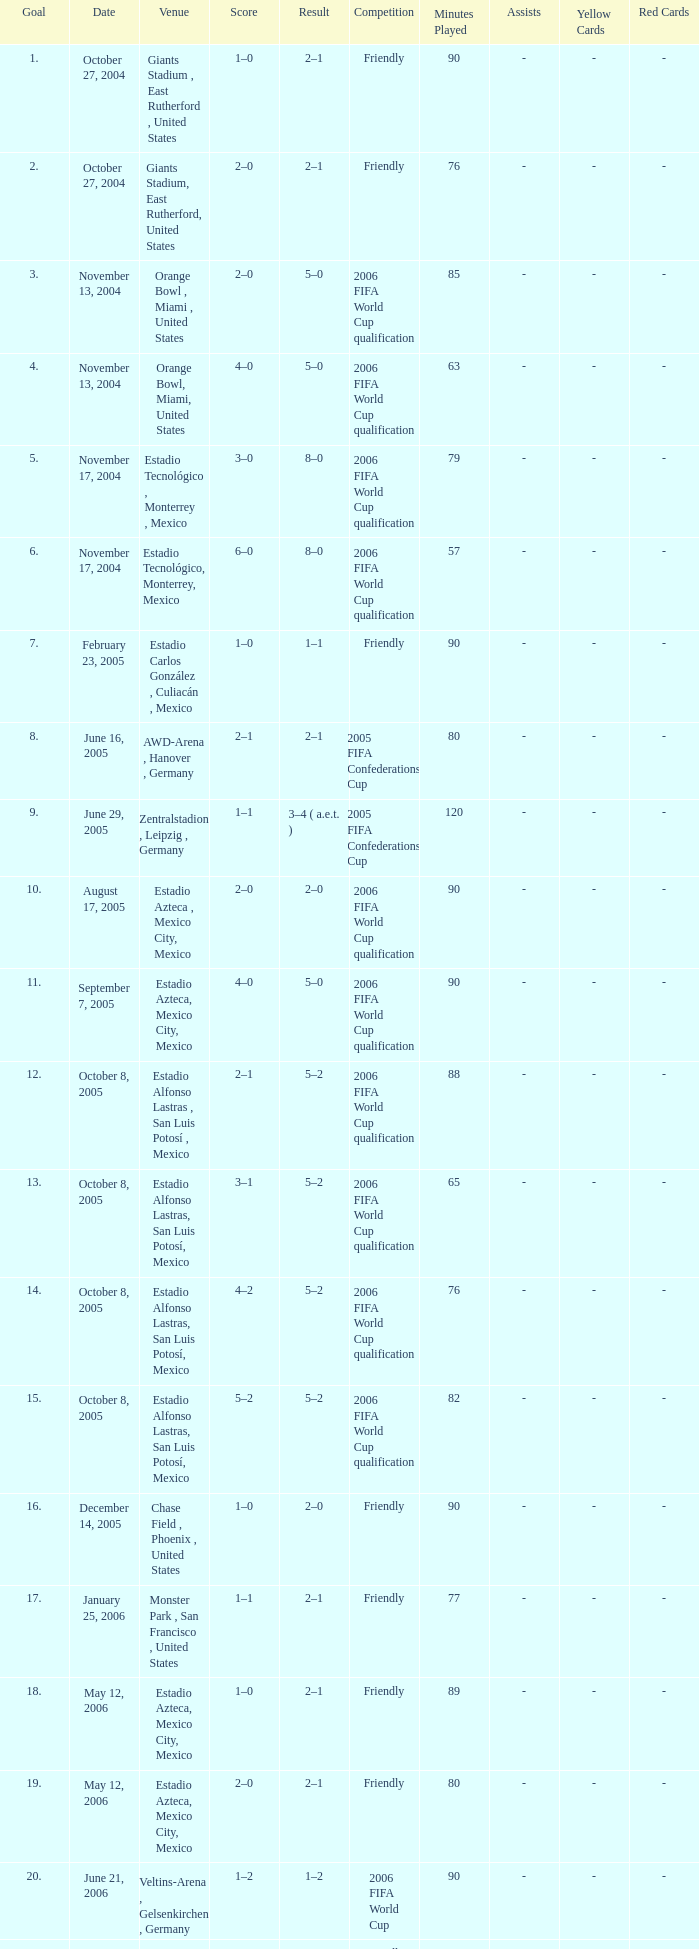Which Score has a Result of 2–1, and a Competition of friendly, and a Goal smaller than 17? 1–0, 2–0. 